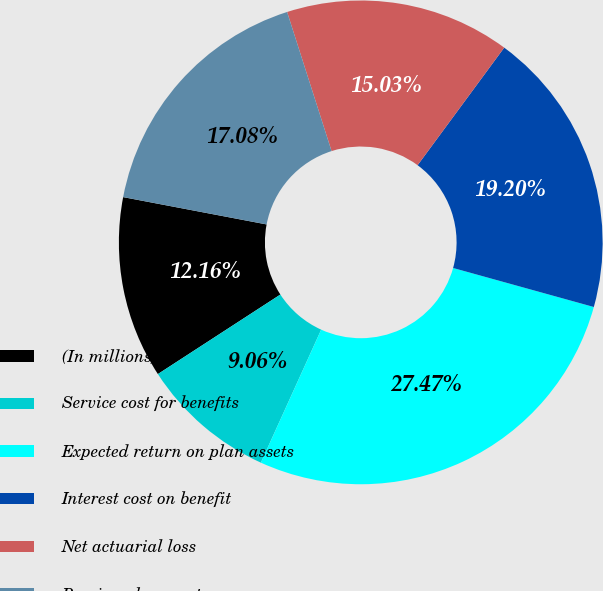Convert chart to OTSL. <chart><loc_0><loc_0><loc_500><loc_500><pie_chart><fcel>(In millions)<fcel>Service cost for benefits<fcel>Expected return on plan assets<fcel>Interest cost on benefit<fcel>Net actuarial loss<fcel>Pension plans cost<nl><fcel>12.16%<fcel>9.06%<fcel>27.47%<fcel>19.2%<fcel>15.03%<fcel>17.08%<nl></chart> 